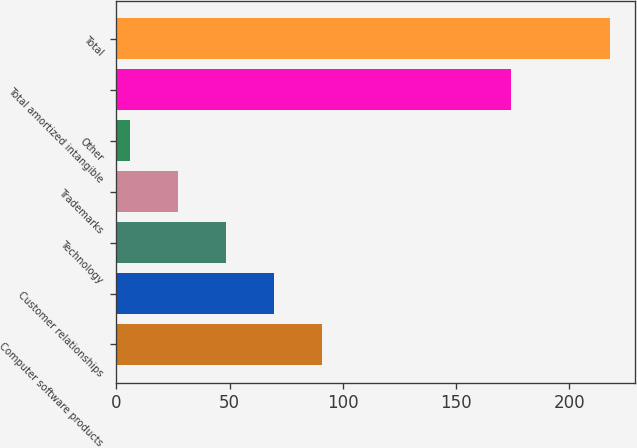<chart> <loc_0><loc_0><loc_500><loc_500><bar_chart><fcel>Computer software products<fcel>Customer relationships<fcel>Technology<fcel>Trademarks<fcel>Other<fcel>Total amortized intangible<fcel>Total<nl><fcel>90.74<fcel>69.53<fcel>48.32<fcel>27.11<fcel>5.9<fcel>174.3<fcel>218<nl></chart> 